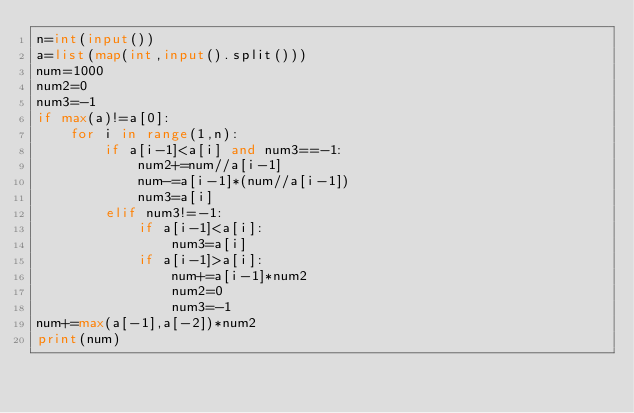<code> <loc_0><loc_0><loc_500><loc_500><_Python_>n=int(input())
a=list(map(int,input().split()))
num=1000
num2=0
num3=-1
if max(a)!=a[0]:
    for i in range(1,n):
        if a[i-1]<a[i] and num3==-1:
            num2+=num//a[i-1]
            num-=a[i-1]*(num//a[i-1])
            num3=a[i]
        elif num3!=-1:
            if a[i-1]<a[i]:
                num3=a[i]
            if a[i-1]>a[i]:
                num+=a[i-1]*num2
                num2=0
                num3=-1
num+=max(a[-1],a[-2])*num2
print(num)
</code> 